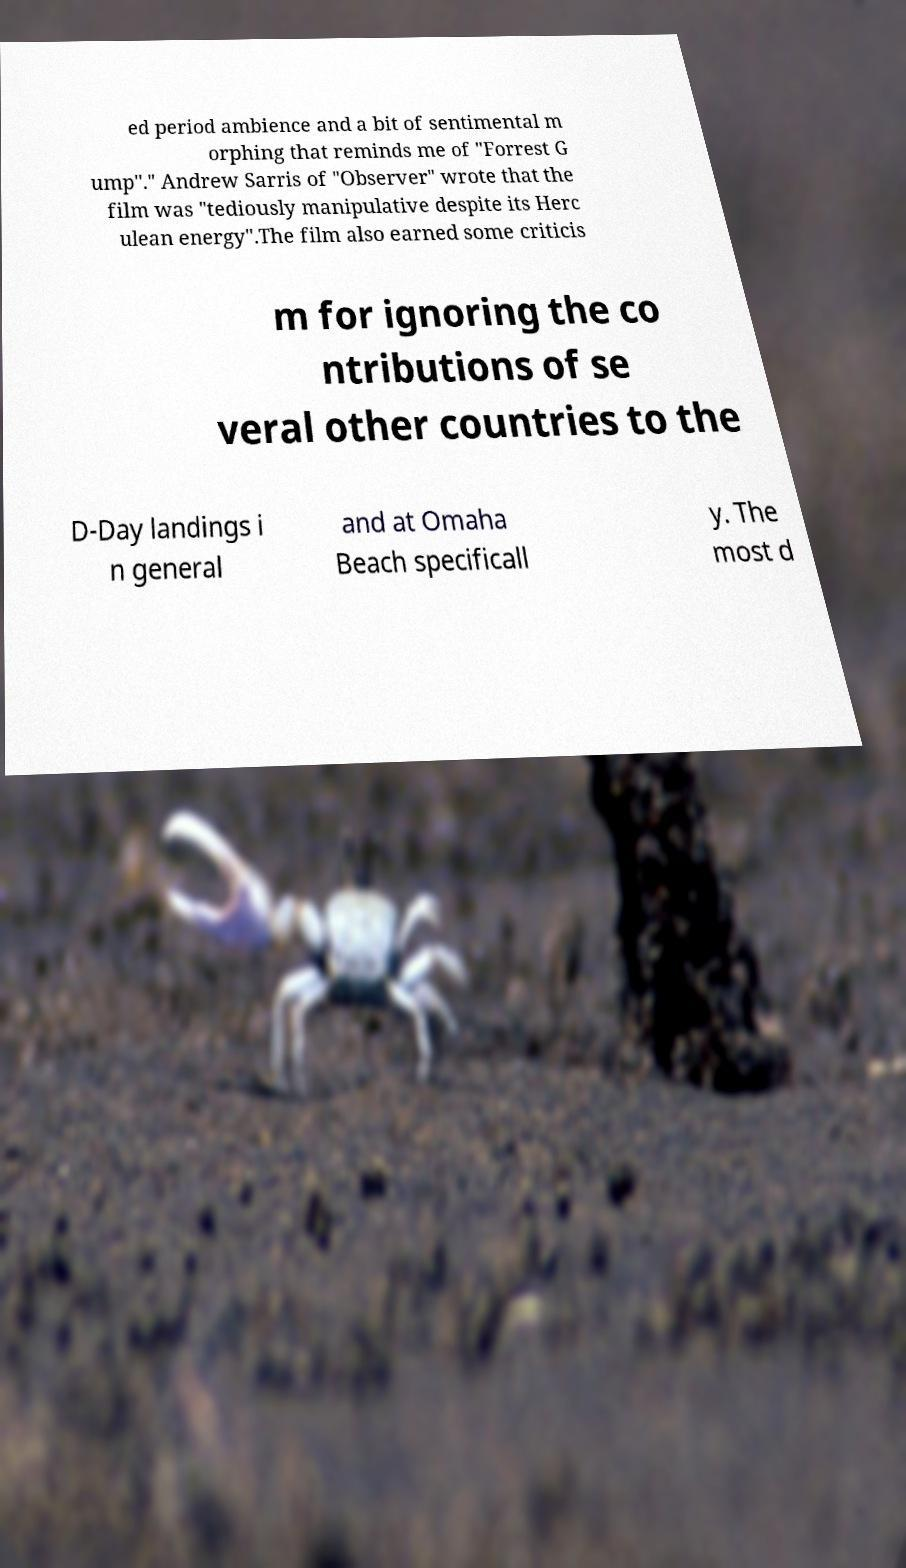For documentation purposes, I need the text within this image transcribed. Could you provide that? ed period ambience and a bit of sentimental m orphing that reminds me of "Forrest G ump"." Andrew Sarris of "Observer" wrote that the film was "tediously manipulative despite its Herc ulean energy".The film also earned some criticis m for ignoring the co ntributions of se veral other countries to the D-Day landings i n general and at Omaha Beach specificall y. The most d 